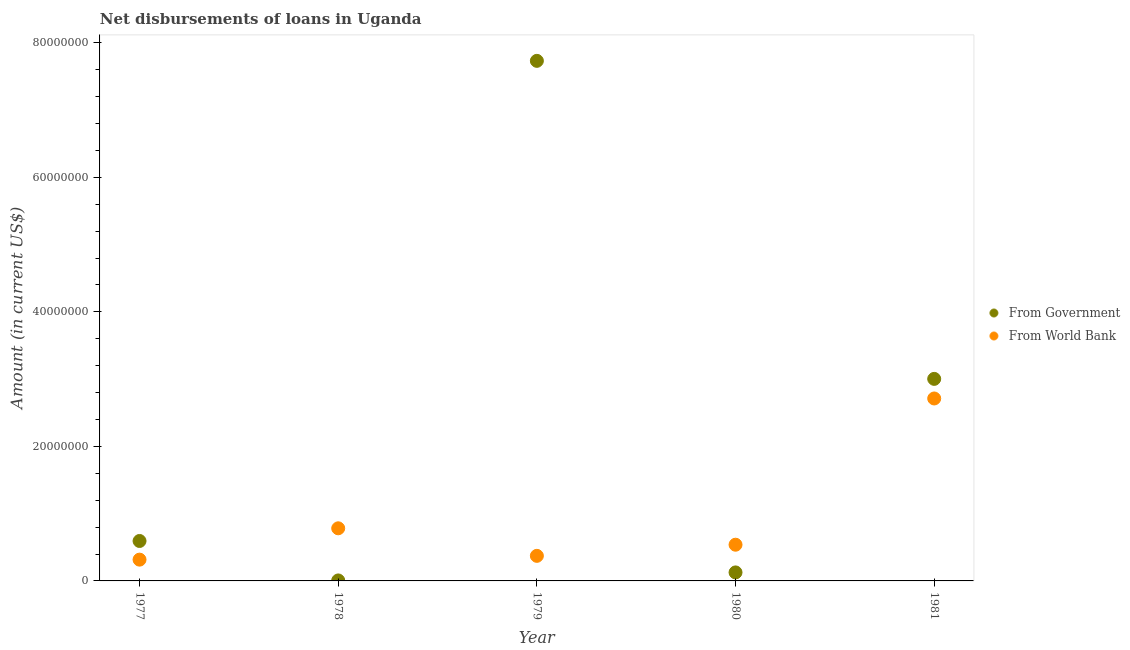Is the number of dotlines equal to the number of legend labels?
Give a very brief answer. Yes. What is the net disbursements of loan from world bank in 1977?
Your answer should be compact. 3.16e+06. Across all years, what is the maximum net disbursements of loan from government?
Ensure brevity in your answer.  7.73e+07. Across all years, what is the minimum net disbursements of loan from world bank?
Your answer should be compact. 3.16e+06. In which year was the net disbursements of loan from government maximum?
Ensure brevity in your answer.  1979. What is the total net disbursements of loan from government in the graph?
Offer a terse response. 1.15e+08. What is the difference between the net disbursements of loan from world bank in 1977 and that in 1981?
Keep it short and to the point. -2.40e+07. What is the difference between the net disbursements of loan from government in 1978 and the net disbursements of loan from world bank in 1977?
Keep it short and to the point. -3.09e+06. What is the average net disbursements of loan from government per year?
Provide a succinct answer. 2.29e+07. In the year 1978, what is the difference between the net disbursements of loan from world bank and net disbursements of loan from government?
Make the answer very short. 7.75e+06. What is the ratio of the net disbursements of loan from government in 1977 to that in 1980?
Offer a terse response. 4.69. Is the net disbursements of loan from government in 1980 less than that in 1981?
Give a very brief answer. Yes. What is the difference between the highest and the second highest net disbursements of loan from government?
Make the answer very short. 4.73e+07. What is the difference between the highest and the lowest net disbursements of loan from world bank?
Give a very brief answer. 2.40e+07. In how many years, is the net disbursements of loan from world bank greater than the average net disbursements of loan from world bank taken over all years?
Your response must be concise. 1. Does the net disbursements of loan from world bank monotonically increase over the years?
Make the answer very short. No. Is the net disbursements of loan from government strictly less than the net disbursements of loan from world bank over the years?
Your response must be concise. No. How many years are there in the graph?
Provide a succinct answer. 5. Are the values on the major ticks of Y-axis written in scientific E-notation?
Your response must be concise. No. What is the title of the graph?
Keep it short and to the point. Net disbursements of loans in Uganda. What is the label or title of the Y-axis?
Offer a terse response. Amount (in current US$). What is the Amount (in current US$) of From Government in 1977?
Your answer should be compact. 5.94e+06. What is the Amount (in current US$) in From World Bank in 1977?
Provide a short and direct response. 3.16e+06. What is the Amount (in current US$) of From Government in 1978?
Provide a short and direct response. 7.20e+04. What is the Amount (in current US$) in From World Bank in 1978?
Give a very brief answer. 7.82e+06. What is the Amount (in current US$) of From Government in 1979?
Keep it short and to the point. 7.73e+07. What is the Amount (in current US$) of From World Bank in 1979?
Provide a succinct answer. 3.73e+06. What is the Amount (in current US$) in From Government in 1980?
Offer a terse response. 1.26e+06. What is the Amount (in current US$) in From World Bank in 1980?
Offer a terse response. 5.38e+06. What is the Amount (in current US$) of From Government in 1981?
Your response must be concise. 3.00e+07. What is the Amount (in current US$) of From World Bank in 1981?
Your answer should be very brief. 2.71e+07. Across all years, what is the maximum Amount (in current US$) of From Government?
Keep it short and to the point. 7.73e+07. Across all years, what is the maximum Amount (in current US$) in From World Bank?
Offer a very short reply. 2.71e+07. Across all years, what is the minimum Amount (in current US$) in From Government?
Your response must be concise. 7.20e+04. Across all years, what is the minimum Amount (in current US$) in From World Bank?
Provide a succinct answer. 3.16e+06. What is the total Amount (in current US$) of From Government in the graph?
Provide a short and direct response. 1.15e+08. What is the total Amount (in current US$) in From World Bank in the graph?
Give a very brief answer. 4.72e+07. What is the difference between the Amount (in current US$) in From Government in 1977 and that in 1978?
Offer a very short reply. 5.87e+06. What is the difference between the Amount (in current US$) of From World Bank in 1977 and that in 1978?
Offer a very short reply. -4.66e+06. What is the difference between the Amount (in current US$) in From Government in 1977 and that in 1979?
Your response must be concise. -7.14e+07. What is the difference between the Amount (in current US$) of From World Bank in 1977 and that in 1979?
Make the answer very short. -5.64e+05. What is the difference between the Amount (in current US$) in From Government in 1977 and that in 1980?
Offer a very short reply. 4.67e+06. What is the difference between the Amount (in current US$) of From World Bank in 1977 and that in 1980?
Ensure brevity in your answer.  -2.22e+06. What is the difference between the Amount (in current US$) in From Government in 1977 and that in 1981?
Give a very brief answer. -2.41e+07. What is the difference between the Amount (in current US$) in From World Bank in 1977 and that in 1981?
Provide a short and direct response. -2.40e+07. What is the difference between the Amount (in current US$) in From Government in 1978 and that in 1979?
Provide a succinct answer. -7.73e+07. What is the difference between the Amount (in current US$) in From World Bank in 1978 and that in 1979?
Ensure brevity in your answer.  4.10e+06. What is the difference between the Amount (in current US$) of From Government in 1978 and that in 1980?
Your answer should be compact. -1.19e+06. What is the difference between the Amount (in current US$) in From World Bank in 1978 and that in 1980?
Provide a succinct answer. 2.44e+06. What is the difference between the Amount (in current US$) in From Government in 1978 and that in 1981?
Your answer should be very brief. -3.00e+07. What is the difference between the Amount (in current US$) in From World Bank in 1978 and that in 1981?
Provide a short and direct response. -1.93e+07. What is the difference between the Amount (in current US$) in From Government in 1979 and that in 1980?
Your answer should be very brief. 7.61e+07. What is the difference between the Amount (in current US$) in From World Bank in 1979 and that in 1980?
Give a very brief answer. -1.66e+06. What is the difference between the Amount (in current US$) of From Government in 1979 and that in 1981?
Provide a succinct answer. 4.73e+07. What is the difference between the Amount (in current US$) of From World Bank in 1979 and that in 1981?
Your response must be concise. -2.34e+07. What is the difference between the Amount (in current US$) of From Government in 1980 and that in 1981?
Provide a succinct answer. -2.88e+07. What is the difference between the Amount (in current US$) of From World Bank in 1980 and that in 1981?
Your answer should be compact. -2.17e+07. What is the difference between the Amount (in current US$) in From Government in 1977 and the Amount (in current US$) in From World Bank in 1978?
Keep it short and to the point. -1.88e+06. What is the difference between the Amount (in current US$) in From Government in 1977 and the Amount (in current US$) in From World Bank in 1979?
Provide a succinct answer. 2.21e+06. What is the difference between the Amount (in current US$) in From Government in 1977 and the Amount (in current US$) in From World Bank in 1980?
Your response must be concise. 5.55e+05. What is the difference between the Amount (in current US$) in From Government in 1977 and the Amount (in current US$) in From World Bank in 1981?
Provide a succinct answer. -2.12e+07. What is the difference between the Amount (in current US$) in From Government in 1978 and the Amount (in current US$) in From World Bank in 1979?
Provide a succinct answer. -3.66e+06. What is the difference between the Amount (in current US$) of From Government in 1978 and the Amount (in current US$) of From World Bank in 1980?
Provide a succinct answer. -5.31e+06. What is the difference between the Amount (in current US$) in From Government in 1978 and the Amount (in current US$) in From World Bank in 1981?
Provide a succinct answer. -2.71e+07. What is the difference between the Amount (in current US$) in From Government in 1979 and the Amount (in current US$) in From World Bank in 1980?
Make the answer very short. 7.19e+07. What is the difference between the Amount (in current US$) of From Government in 1979 and the Amount (in current US$) of From World Bank in 1981?
Provide a short and direct response. 5.02e+07. What is the difference between the Amount (in current US$) of From Government in 1980 and the Amount (in current US$) of From World Bank in 1981?
Your answer should be compact. -2.59e+07. What is the average Amount (in current US$) in From Government per year?
Make the answer very short. 2.29e+07. What is the average Amount (in current US$) of From World Bank per year?
Your answer should be very brief. 9.44e+06. In the year 1977, what is the difference between the Amount (in current US$) of From Government and Amount (in current US$) of From World Bank?
Offer a terse response. 2.77e+06. In the year 1978, what is the difference between the Amount (in current US$) of From Government and Amount (in current US$) of From World Bank?
Keep it short and to the point. -7.75e+06. In the year 1979, what is the difference between the Amount (in current US$) in From Government and Amount (in current US$) in From World Bank?
Your response must be concise. 7.36e+07. In the year 1980, what is the difference between the Amount (in current US$) of From Government and Amount (in current US$) of From World Bank?
Ensure brevity in your answer.  -4.12e+06. In the year 1981, what is the difference between the Amount (in current US$) of From Government and Amount (in current US$) of From World Bank?
Your answer should be compact. 2.92e+06. What is the ratio of the Amount (in current US$) of From Government in 1977 to that in 1978?
Make the answer very short. 82.47. What is the ratio of the Amount (in current US$) of From World Bank in 1977 to that in 1978?
Give a very brief answer. 0.4. What is the ratio of the Amount (in current US$) in From Government in 1977 to that in 1979?
Your answer should be compact. 0.08. What is the ratio of the Amount (in current US$) in From World Bank in 1977 to that in 1979?
Offer a very short reply. 0.85. What is the ratio of the Amount (in current US$) in From Government in 1977 to that in 1980?
Give a very brief answer. 4.69. What is the ratio of the Amount (in current US$) of From World Bank in 1977 to that in 1980?
Give a very brief answer. 0.59. What is the ratio of the Amount (in current US$) of From Government in 1977 to that in 1981?
Ensure brevity in your answer.  0.2. What is the ratio of the Amount (in current US$) in From World Bank in 1977 to that in 1981?
Your answer should be very brief. 0.12. What is the ratio of the Amount (in current US$) of From Government in 1978 to that in 1979?
Give a very brief answer. 0. What is the ratio of the Amount (in current US$) in From World Bank in 1978 to that in 1979?
Keep it short and to the point. 2.1. What is the ratio of the Amount (in current US$) in From Government in 1978 to that in 1980?
Ensure brevity in your answer.  0.06. What is the ratio of the Amount (in current US$) of From World Bank in 1978 to that in 1980?
Provide a short and direct response. 1.45. What is the ratio of the Amount (in current US$) of From Government in 1978 to that in 1981?
Provide a succinct answer. 0. What is the ratio of the Amount (in current US$) in From World Bank in 1978 to that in 1981?
Offer a terse response. 0.29. What is the ratio of the Amount (in current US$) in From Government in 1979 to that in 1980?
Your answer should be compact. 61.12. What is the ratio of the Amount (in current US$) in From World Bank in 1979 to that in 1980?
Your answer should be very brief. 0.69. What is the ratio of the Amount (in current US$) of From Government in 1979 to that in 1981?
Provide a succinct answer. 2.57. What is the ratio of the Amount (in current US$) in From World Bank in 1979 to that in 1981?
Offer a very short reply. 0.14. What is the ratio of the Amount (in current US$) of From Government in 1980 to that in 1981?
Offer a very short reply. 0.04. What is the ratio of the Amount (in current US$) of From World Bank in 1980 to that in 1981?
Give a very brief answer. 0.2. What is the difference between the highest and the second highest Amount (in current US$) in From Government?
Ensure brevity in your answer.  4.73e+07. What is the difference between the highest and the second highest Amount (in current US$) in From World Bank?
Give a very brief answer. 1.93e+07. What is the difference between the highest and the lowest Amount (in current US$) of From Government?
Ensure brevity in your answer.  7.73e+07. What is the difference between the highest and the lowest Amount (in current US$) in From World Bank?
Ensure brevity in your answer.  2.40e+07. 